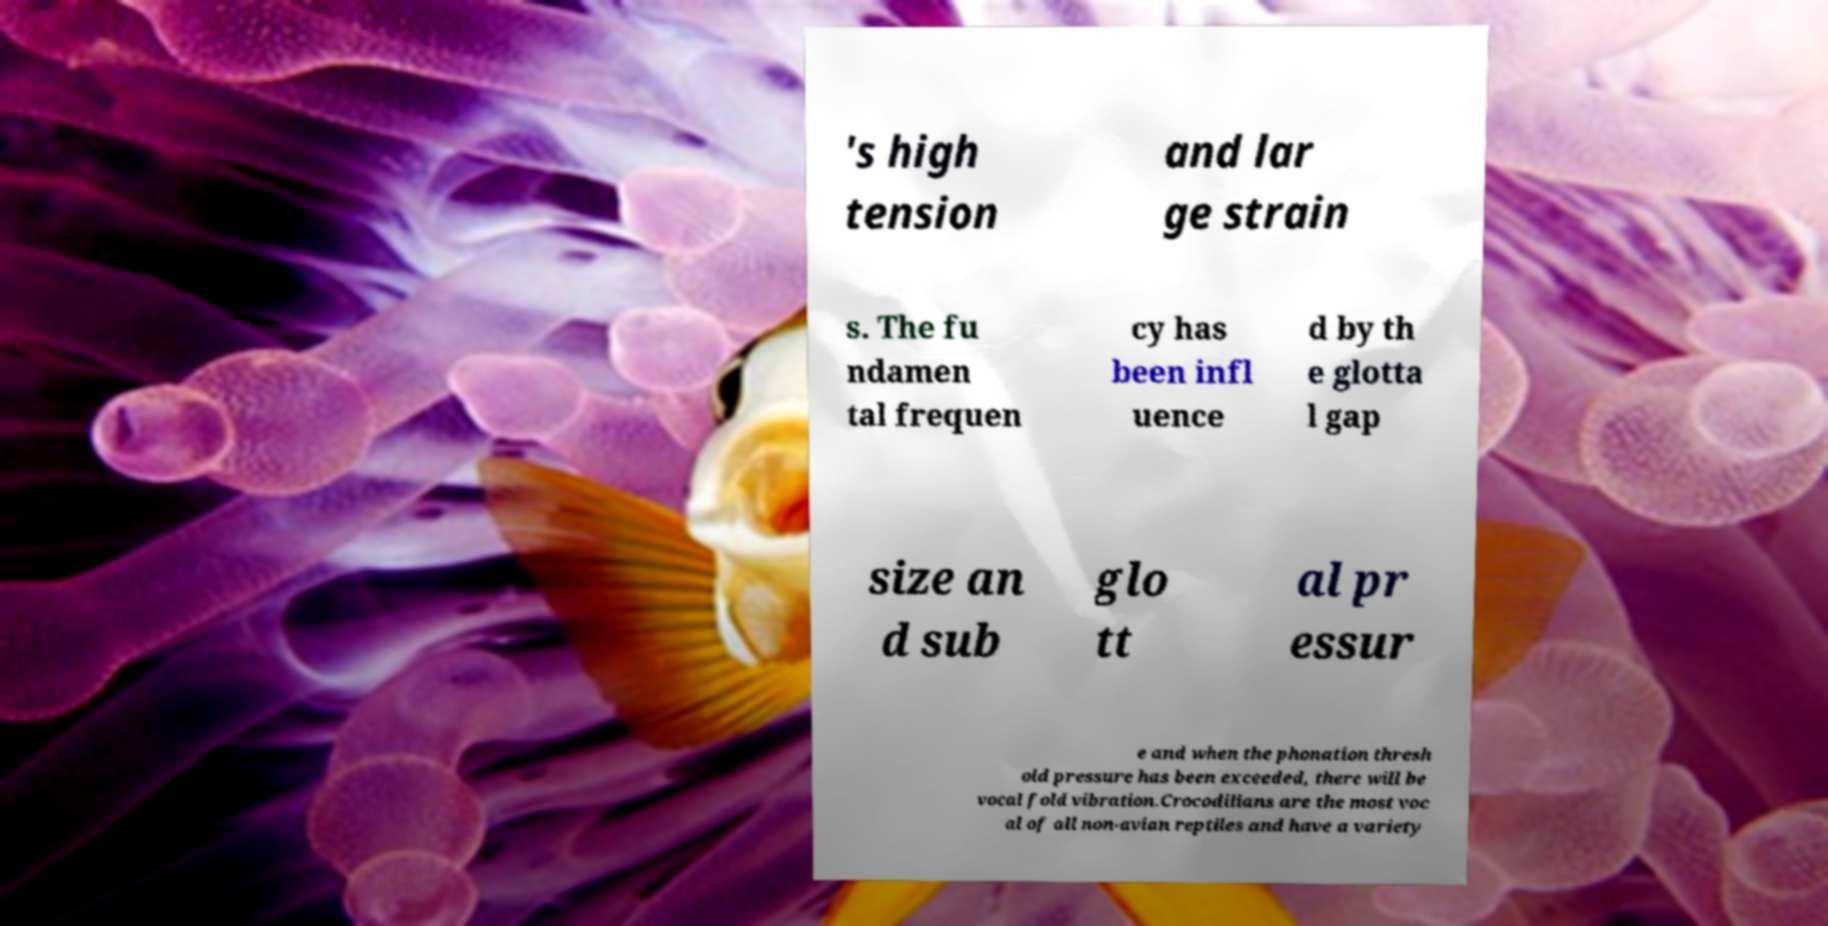Could you extract and type out the text from this image? 's high tension and lar ge strain s. The fu ndamen tal frequen cy has been infl uence d by th e glotta l gap size an d sub glo tt al pr essur e and when the phonation thresh old pressure has been exceeded, there will be vocal fold vibration.Crocodilians are the most voc al of all non-avian reptiles and have a variety 